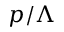<formula> <loc_0><loc_0><loc_500><loc_500>p / \Lambda</formula> 